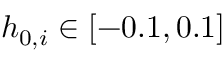<formula> <loc_0><loc_0><loc_500><loc_500>h _ { 0 , i } \in [ - 0 . 1 , 0 . 1 ]</formula> 